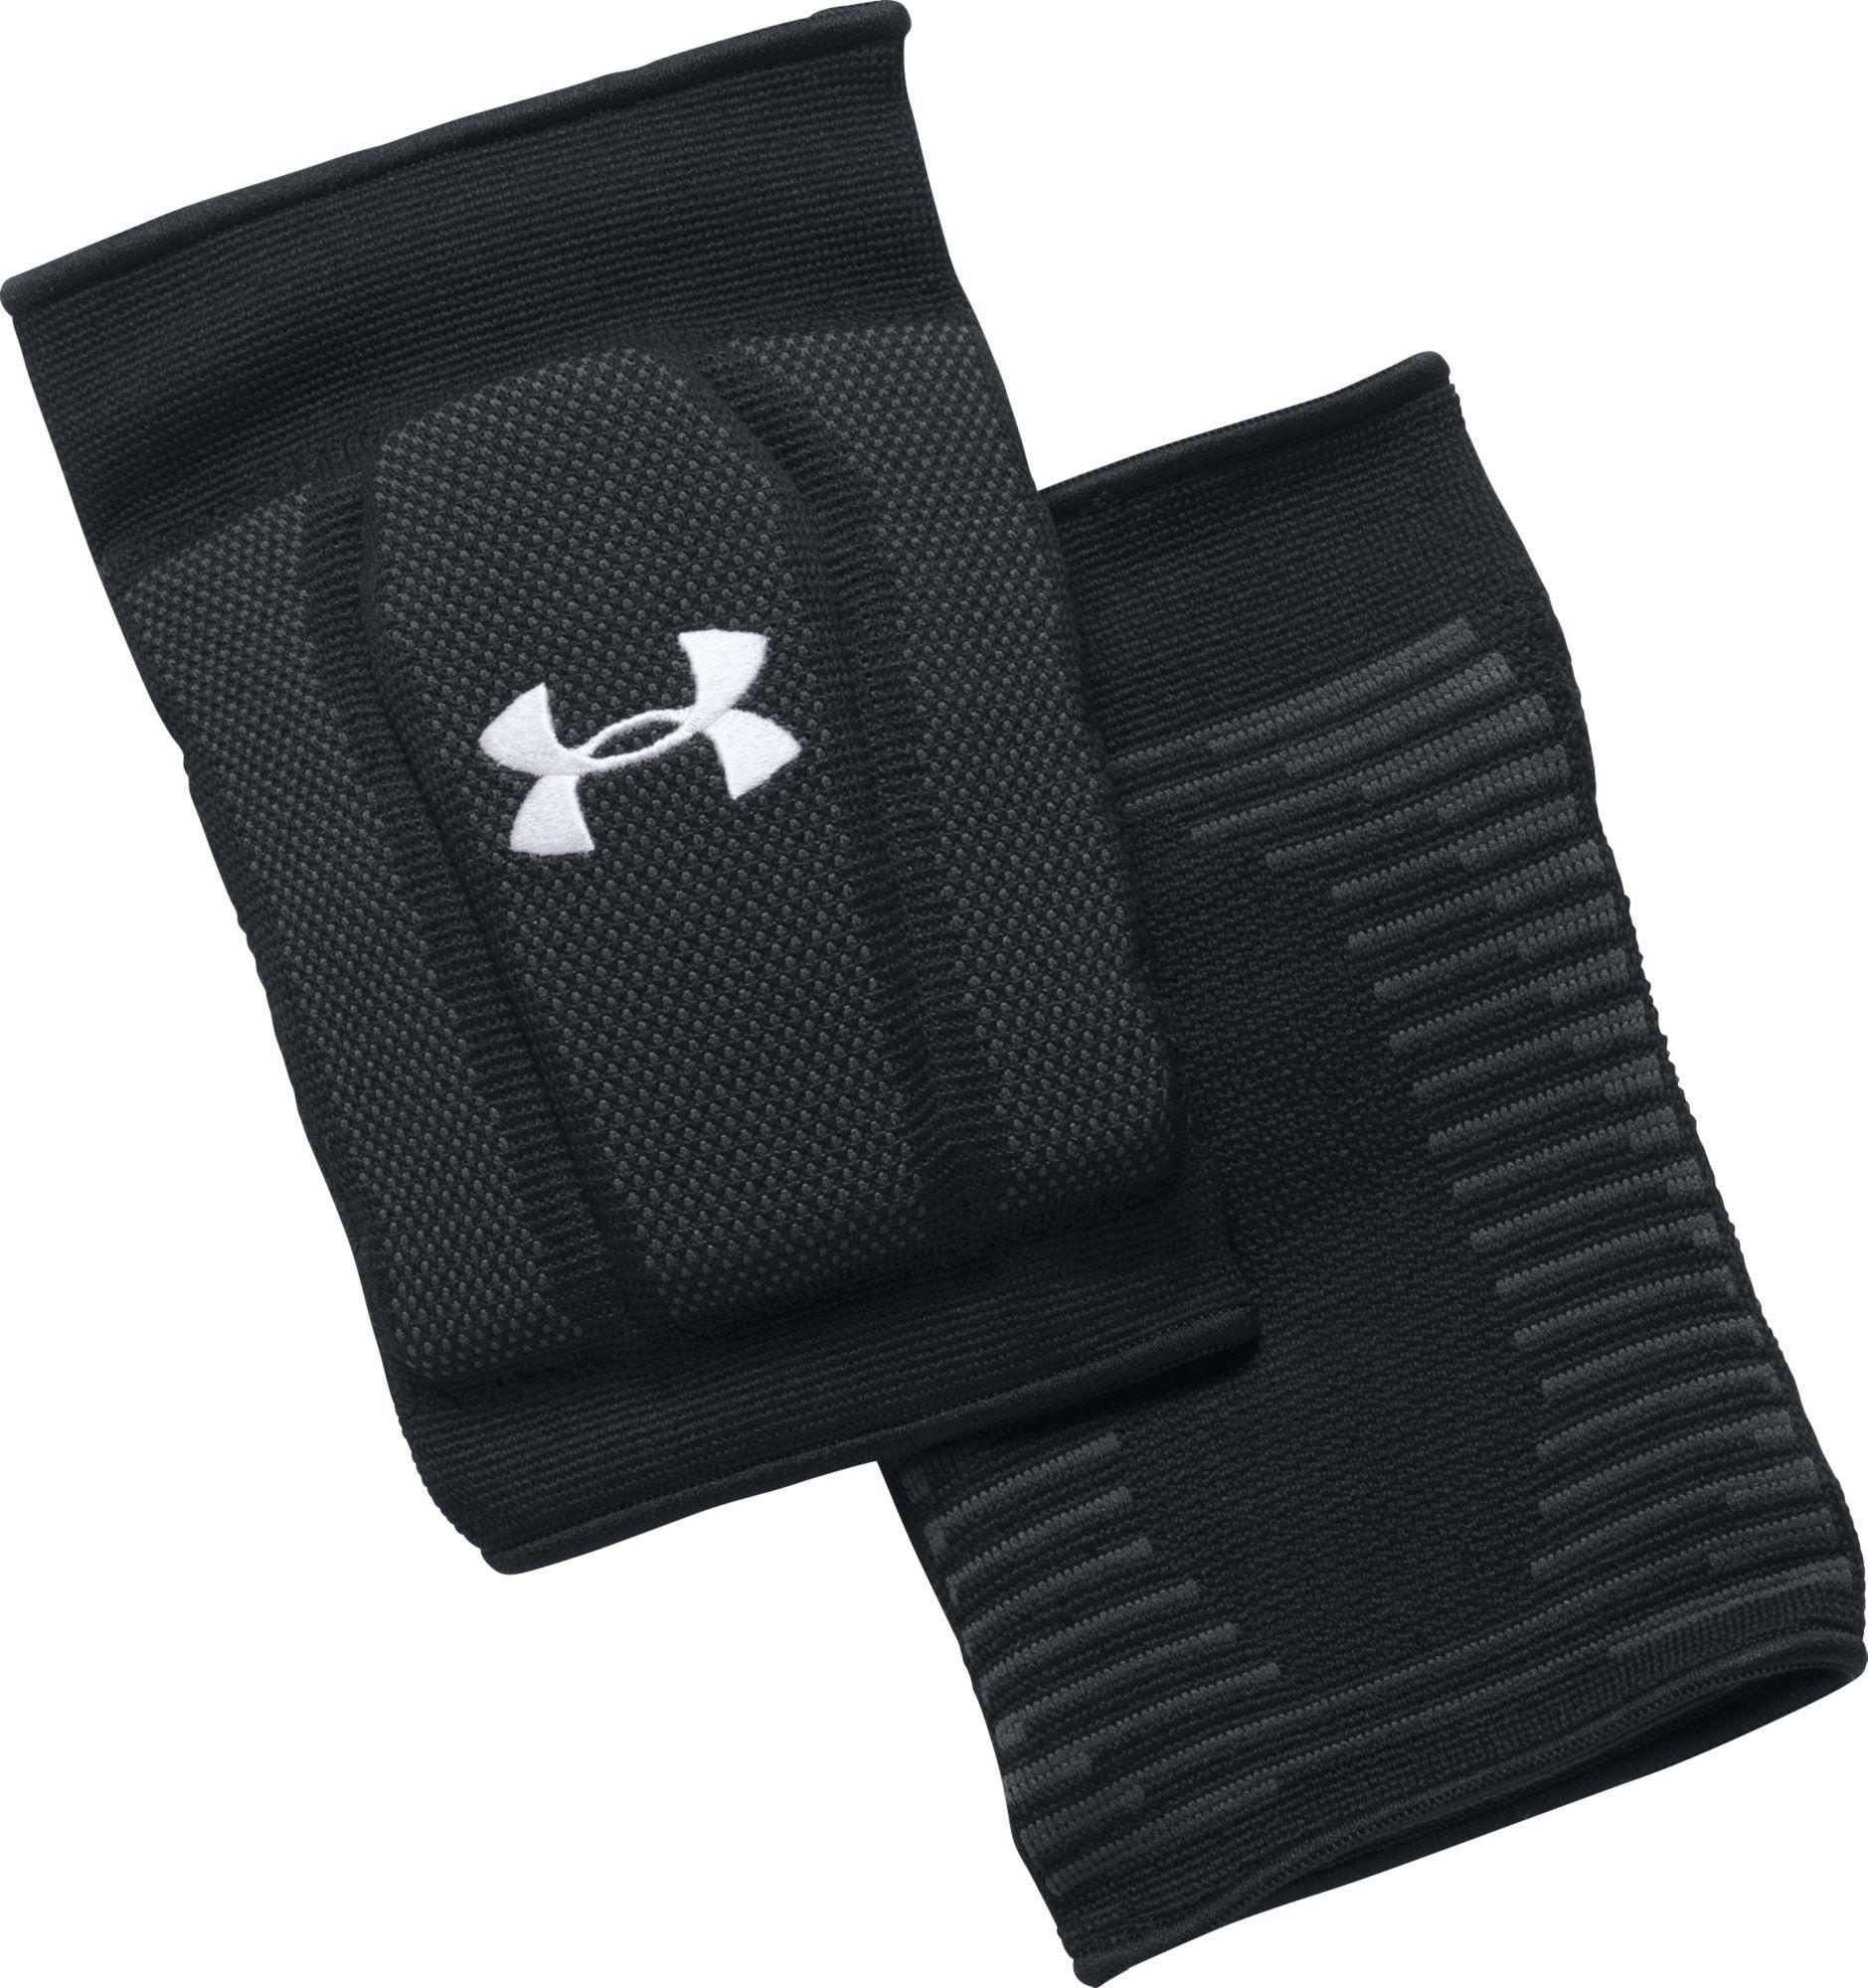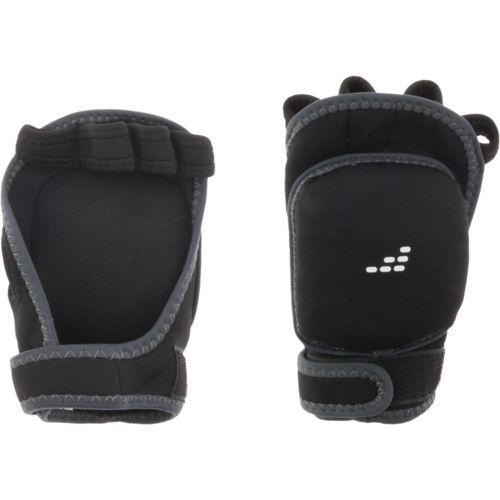The first image is the image on the left, the second image is the image on the right. Analyze the images presented: Is the assertion "A person is modeling the knee pads in one of the images." valid? Answer yes or no. No. The first image is the image on the left, the second image is the image on the right. Assess this claim about the two images: "An image shows a black knee pad modeled on a human leg.". Correct or not? Answer yes or no. No. 